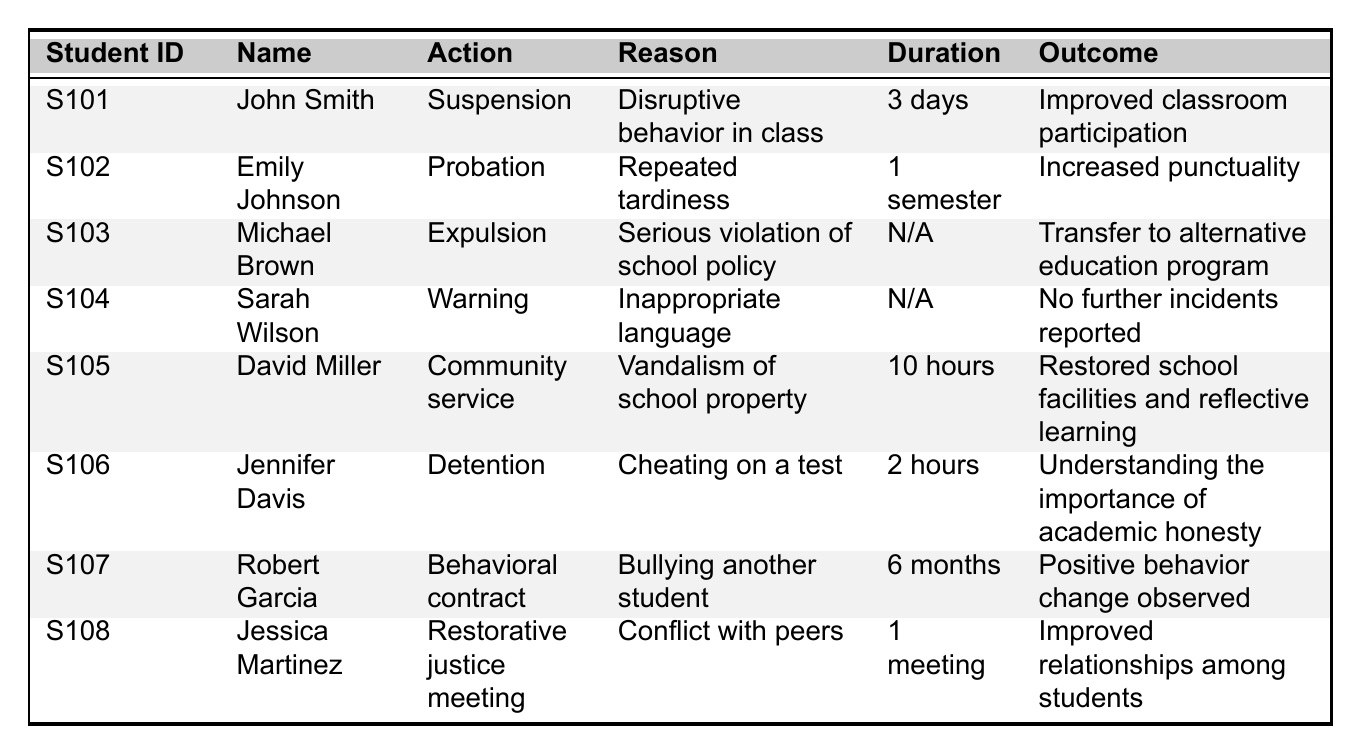What disciplinary action was taken against John Smith? According to the table, John Smith was given a suspension due to disruptive behavior in class.
Answer: Suspension How long was Emily Johnson on probation? The table indicates that Emily Johnson was on probation for 1 semester due to repeated tardiness.
Answer: 1 semester Was David Miller assigned community service for cheating? The table shows that David Miller was assigned community service for vandalism of school property, not for cheating.
Answer: No What was the outcome of Jennifer Davis's detention for cheating? From the table, the outcome of Jennifer Davis's detention was understanding the importance of academic honesty.
Answer: Understanding the importance of academic honesty Which student received an expulsion, and what was the reason? The table reveals that Michael Brown received an expulsion for a serious violation of school policy.
Answer: Michael Brown; serious violation of school policy How many students received a warning? The table lists one student, Sarah Wilson, who received a warning for inappropriate language.
Answer: 1 What total duration of community service was assigned? The table states that David Miller was assigned 10 hours of community service.
Answer: 10 hours What was the duration of the behavioral contract for Robert Garcia? According to the table, Robert Garcia had a behavioral contract for a duration of 6 months due to bullying another student.
Answer: 6 months Did any students experience improved relationships as a result of their disciplinary actions? Yes, the table indicates that Jessica Martinez's restorative justice meeting led to improved relationships among students.
Answer: Yes Which disciplinary action had the longest duration? In the table, the behavioral contract for Robert Garcia is the longest at 6 months; it exceeds other duration mentioned, including probation and community service.
Answer: Behavioral contract 